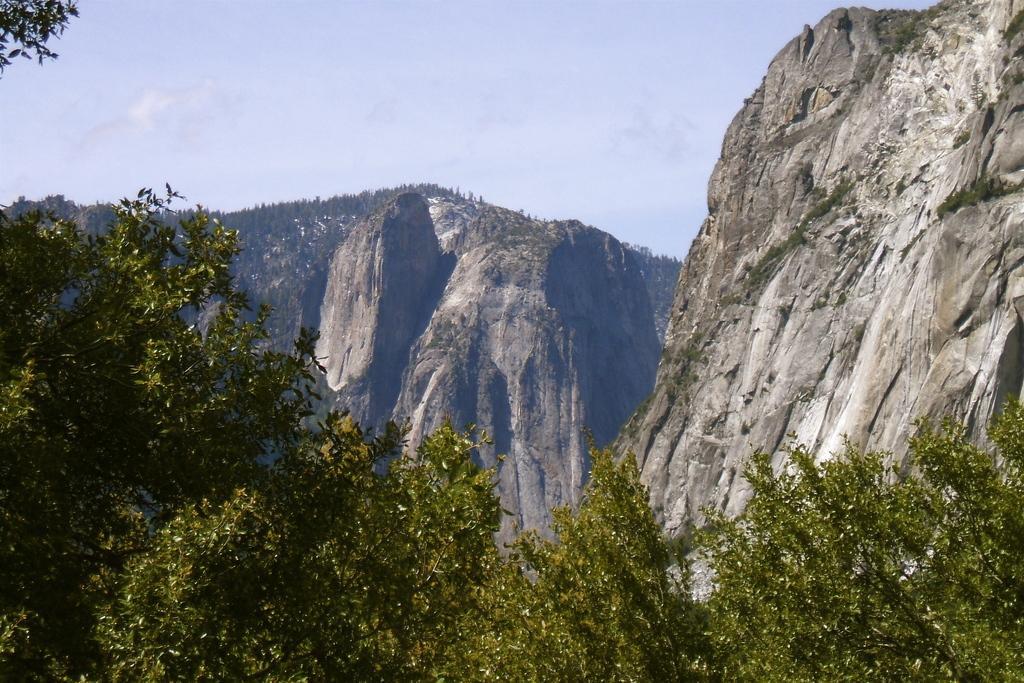Please provide a concise description of this image. In the foreground of this image, there are trees. In the middle, there are mountains. At the top, there is the sky. 